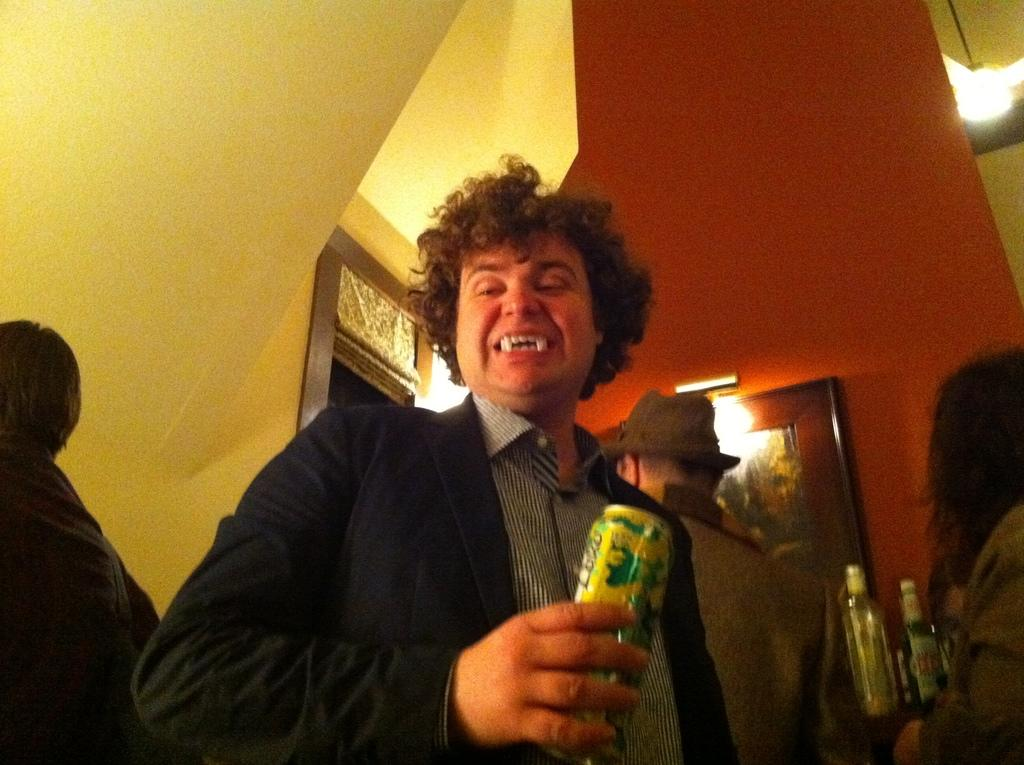What is the man in the image doing? The man is standing in the image and holding a tin in his hand. Can you describe the background of the image? In the background, there is a group of persons standing, a rack with wine bottles, a frame, a door, and a light. What might the man be holding the tin for? It is not clear from the image what the man is using the tin for, but it could be for holding or serving something. How many people are visible in the background of the image? There is a group of persons standing in the background, but the exact number is not specified. What type of drug can be seen in the man's hand in the image? There is no drug present in the image; the man is holding a tin in his hand. How many pizzas are visible on the rack in the background? There is no rack with pizzas in the image; there is a rack with wine bottles in the background. 